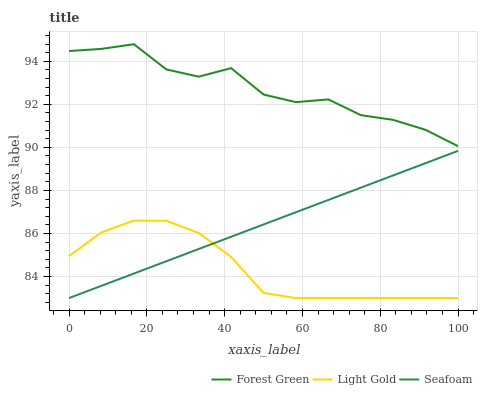Does Light Gold have the minimum area under the curve?
Answer yes or no. Yes. Does Forest Green have the maximum area under the curve?
Answer yes or no. Yes. Does Seafoam have the minimum area under the curve?
Answer yes or no. No. Does Seafoam have the maximum area under the curve?
Answer yes or no. No. Is Seafoam the smoothest?
Answer yes or no. Yes. Is Forest Green the roughest?
Answer yes or no. Yes. Is Light Gold the smoothest?
Answer yes or no. No. Is Light Gold the roughest?
Answer yes or no. No. Does Light Gold have the lowest value?
Answer yes or no. Yes. Does Forest Green have the highest value?
Answer yes or no. Yes. Does Seafoam have the highest value?
Answer yes or no. No. Is Seafoam less than Forest Green?
Answer yes or no. Yes. Is Forest Green greater than Light Gold?
Answer yes or no. Yes. Does Seafoam intersect Light Gold?
Answer yes or no. Yes. Is Seafoam less than Light Gold?
Answer yes or no. No. Is Seafoam greater than Light Gold?
Answer yes or no. No. Does Seafoam intersect Forest Green?
Answer yes or no. No. 